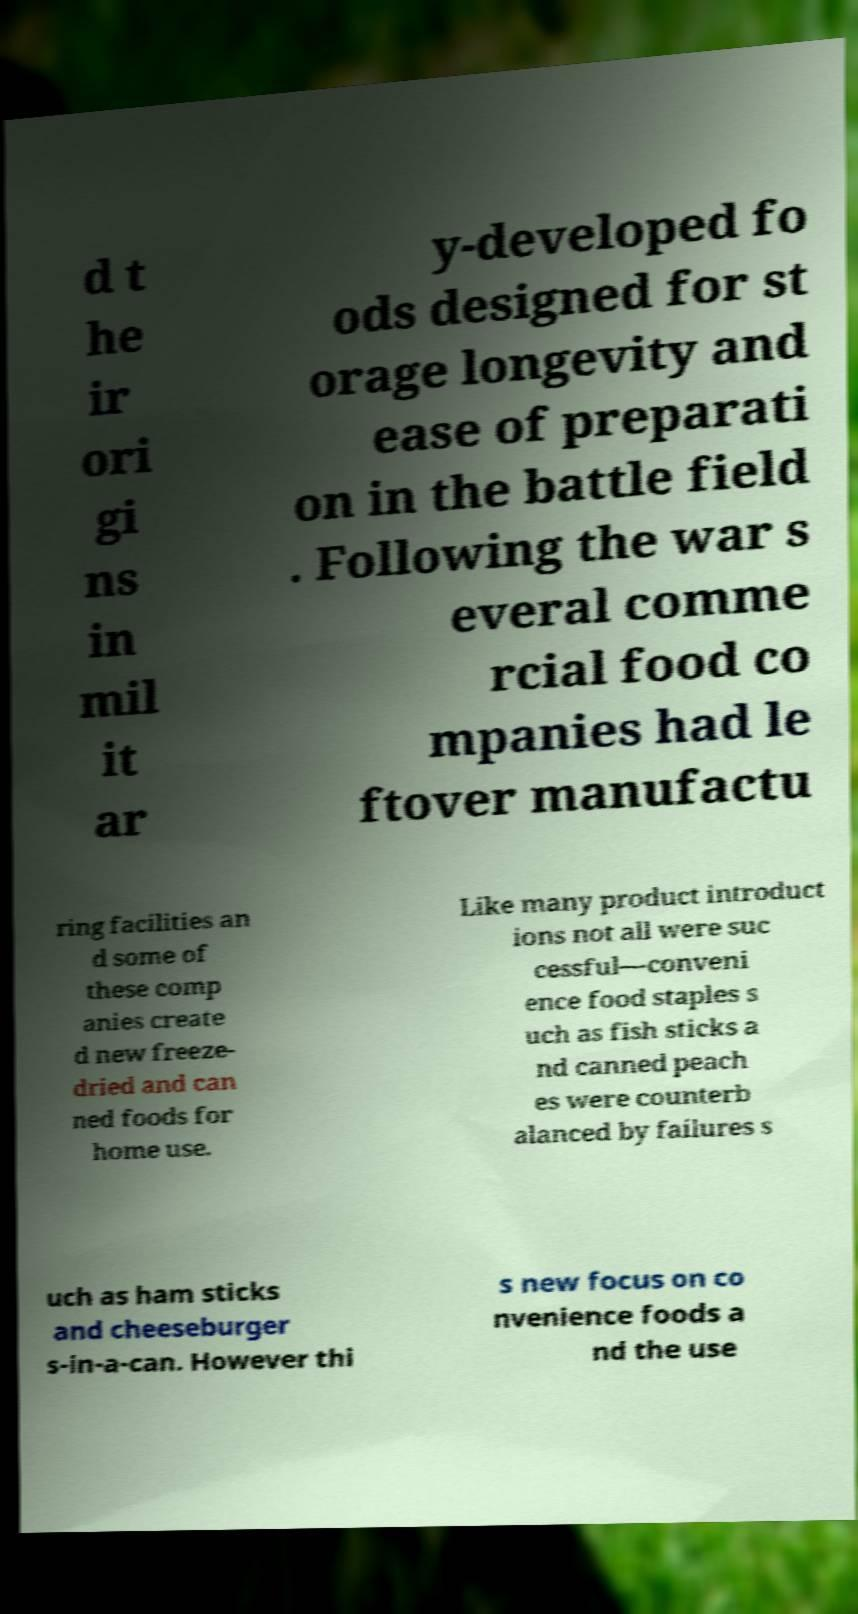Could you assist in decoding the text presented in this image and type it out clearly? d t he ir ori gi ns in mil it ar y-developed fo ods designed for st orage longevity and ease of preparati on in the battle field . Following the war s everal comme rcial food co mpanies had le ftover manufactu ring facilities an d some of these comp anies create d new freeze- dried and can ned foods for home use. Like many product introduct ions not all were suc cessful—conveni ence food staples s uch as fish sticks a nd canned peach es were counterb alanced by failures s uch as ham sticks and cheeseburger s-in-a-can. However thi s new focus on co nvenience foods a nd the use 